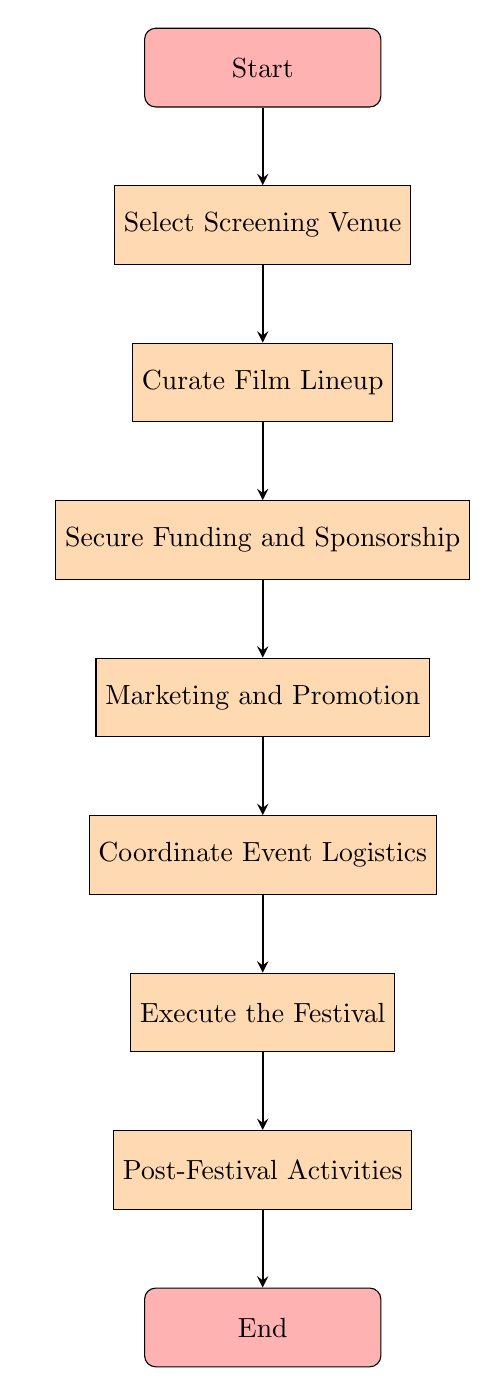What is the first step in the workflow? The first step in the workflow is labeled as "Select Screening Venue," as it is the first process node that follows the "Start" node in the flow chart.
Answer: Select Screening Venue How many main steps are there in the workflow? The flow chart contains seven main process nodes that represent the steps of the workflow, leading from the start to the end of the festival organization process.
Answer: Seven What step comes immediately after "Secure Funding and Sponsorship"? The step that follows "Secure Funding and Sponsorship" is "Marketing and Promotion," which is the next step in the sequence of the flow chart.
Answer: Marketing and Promotion Which step involves contacting community centers? The task "Contact community centers and art galleries" is part of the "Select Screening Venue" step, indicating that venue selection includes outreach efforts to local spaces for screening.
Answer: Select Screening Venue What are the last activities listed in the workflow? The final activities in the workflow are encompassed under the step "Post-Festival Activities," which indicates the procedures conducted after the festival concludes.
Answer: Post-Festival Activities What is the relationship between "Curate Film Lineup" and "Execute the Festival"? "Curate Film Lineup" is a preceding step to "Execute the Festival"; the lineup must be curated before the festival can be executed, showing a sequential relationship in the workflow.
Answer: Sequential relationship What main task is related to engaging with online communities? The task related to engaging with online communities falls under the "Marketing and Promotion" step, indicating that this is a crucial aspect of promoting the festival.
Answer: Marketing and Promotion 